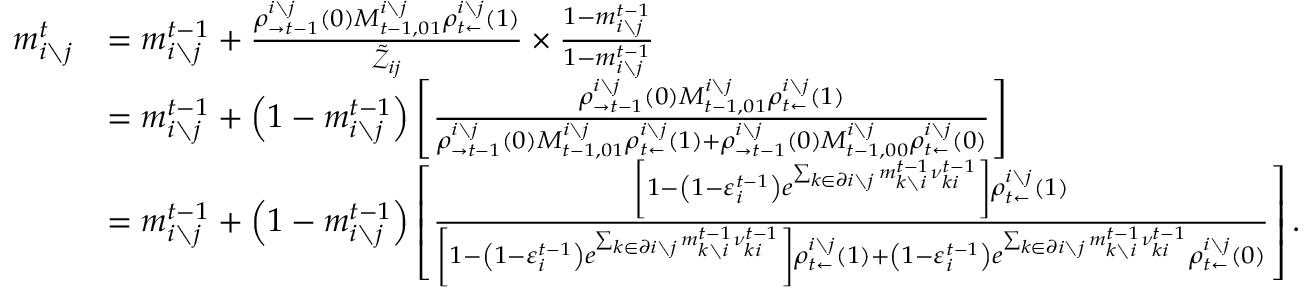Convert formula to latex. <formula><loc_0><loc_0><loc_500><loc_500>\begin{array} { r l } { m _ { i \ j } ^ { t } } & { = m _ { i \ j } ^ { t - 1 } + \frac { \rho _ { \rightarrow t - 1 } ^ { i \ j } \left ( 0 \right ) M _ { t - 1 , 0 1 } ^ { i \ j } \rho _ { t \leftarrow } ^ { i \ j } \left ( 1 \right ) } { \tilde { \mathcal { Z } } _ { i j } } \times \frac { 1 - m _ { i \ j } ^ { t - 1 } } { 1 - m _ { i \ j } ^ { t - 1 } } } \\ & { = m _ { i \ j } ^ { t - 1 } + \left ( 1 - m _ { i \ j } ^ { t - 1 } \right ) \left [ \frac { \rho _ { \rightarrow t - 1 } ^ { i \ j } \left ( 0 \right ) M _ { t - 1 , 0 1 } ^ { i \ j } \rho _ { t \leftarrow } ^ { i \ j } \left ( 1 \right ) } { \rho _ { \rightarrow t - 1 } ^ { i \ j } \left ( 0 \right ) M _ { t - 1 , 0 1 } ^ { i \ j } \rho _ { t \leftarrow } ^ { i \ j } \left ( 1 \right ) + \rho _ { \rightarrow t - 1 } ^ { i \ j } \left ( 0 \right ) M _ { t - 1 , 0 0 } ^ { i \ j } \rho _ { t \leftarrow } ^ { i \ j } \left ( 0 \right ) } \right ] } \\ & { = m _ { i \ j } ^ { t - 1 } + \left ( 1 - m _ { i \ j } ^ { t - 1 } \right ) \left [ \frac { \left [ 1 - \left ( 1 - \varepsilon _ { i } ^ { t - 1 } \right ) e ^ { \sum _ { k \in \partial i \ j } m _ { k \ i } ^ { t - 1 } \nu _ { k i } ^ { t - 1 } } \right ] \rho _ { t \leftarrow } ^ { i \ j } \left ( 1 \right ) } { \left [ 1 - \left ( 1 - \varepsilon _ { i } ^ { t - 1 } \right ) e ^ { \sum _ { k \in \partial i \ j } m _ { k \ i } ^ { t - 1 } \nu _ { k i } ^ { t - 1 } } \right ] \rho _ { t \leftarrow } ^ { i \ j } \left ( 1 \right ) + \left ( 1 - \varepsilon _ { i } ^ { t - 1 } \right ) e ^ { \sum _ { k \in \partial i \ j } m _ { k \ i } ^ { t - 1 } \nu _ { k i } ^ { t - 1 } } \rho _ { t \leftarrow } ^ { i \ j } \left ( 0 \right ) } \right ] . } \end{array}</formula> 